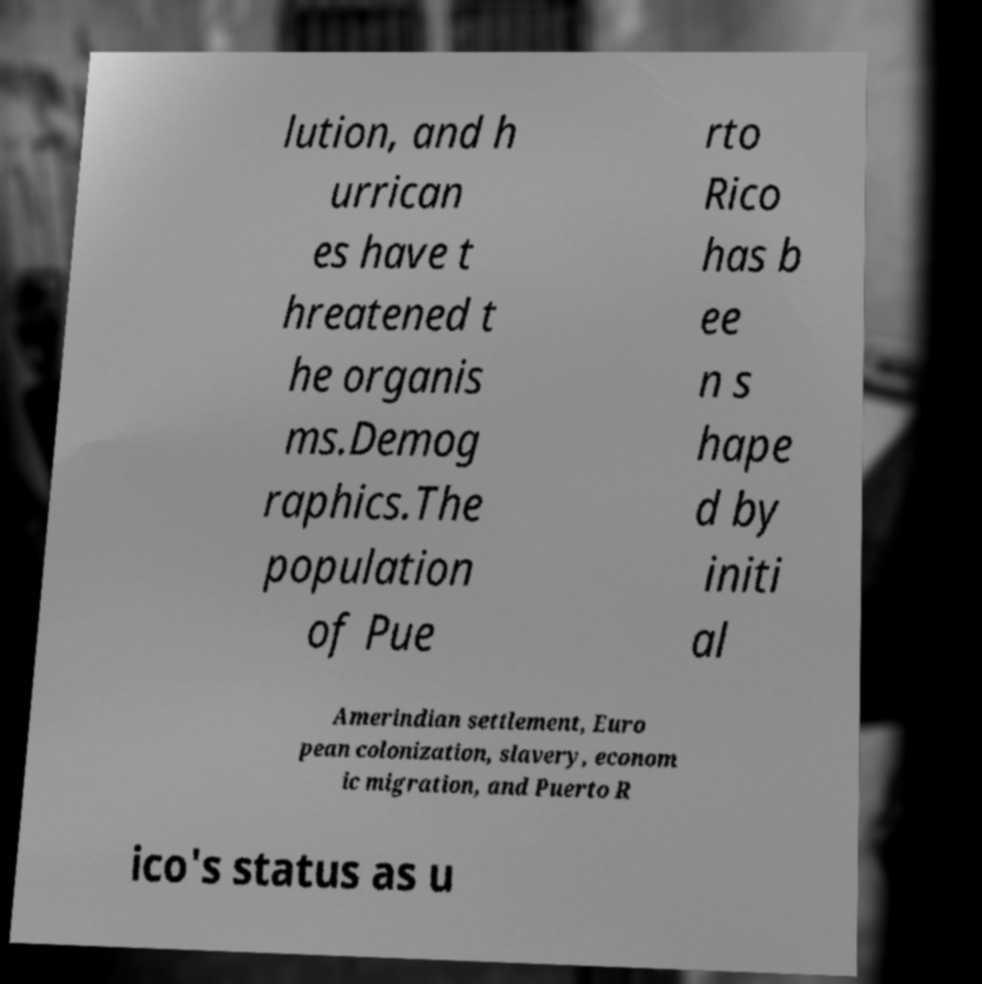Please identify and transcribe the text found in this image. lution, and h urrican es have t hreatened t he organis ms.Demog raphics.The population of Pue rto Rico has b ee n s hape d by initi al Amerindian settlement, Euro pean colonization, slavery, econom ic migration, and Puerto R ico's status as u 